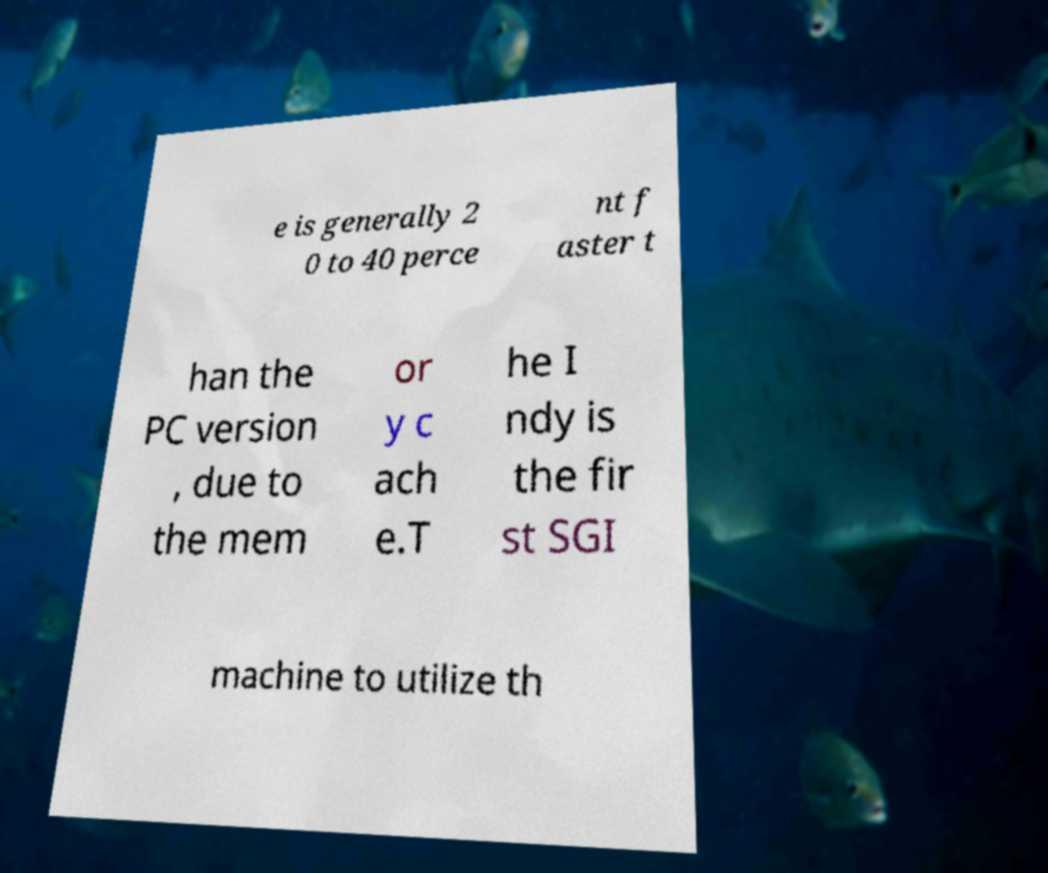There's text embedded in this image that I need extracted. Can you transcribe it verbatim? e is generally 2 0 to 40 perce nt f aster t han the PC version , due to the mem or y c ach e.T he I ndy is the fir st SGI machine to utilize th 